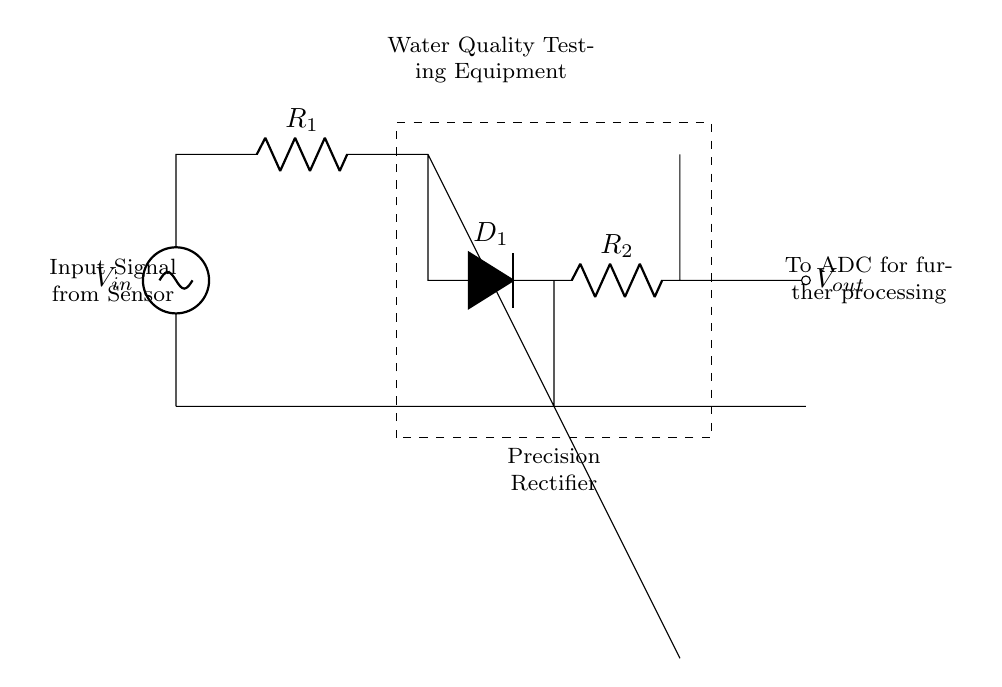What is the input voltage of this circuit? The input voltage is labeled as V in the circuit diagram, which is the voltage applied from the sensor to the precision rectifier.
Answer: V in What is the output signal destination? The output signal, labeled as V out, is directed to an Analog-to-Digital Converter (ADC) for further processing as indicated in the diagram.
Answer: ADC What type of diode is used in this circuit? The circuit uses a precision rectifier, which incorporates a diode labeled as D1. This diode allows for accurate rectification.
Answer: D1 What are the resistors in this circuit? The circuit contains two resistors, R1 and R2, that are essential in the precision rectifier functionality, affecting the gain and impedance characteristics.
Answer: R1, R2 How does the op-amp affect the output? The operational amplifier (op-amp) in the circuit amplifies the input signal and drives the precision rectifier's operation, enabling accurate measurements.
Answer: Amplifies input What is the main purpose of this precision rectifier? The main purpose of the precision rectifier is to convert the input signal from the sensor into a usable output signal for accurate measurements in water quality testing equipment.
Answer: Accurate measurements What does the dashed rectangle signify? The dashed rectangle highlights the portion of the circuit that represents the precision rectifier, visualizing it as a separate functional unit within the overall water quality testing equipment.
Answer: Precision Rectifier 